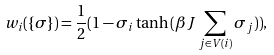Convert formula to latex. <formula><loc_0><loc_0><loc_500><loc_500>w _ { i } ( \{ \sigma \} ) = \frac { 1 } { 2 } ( 1 - \sigma _ { i } \tanh { ( \beta J \sum _ { j \in V ( i ) } \sigma _ { j } ) ) } ,</formula> 